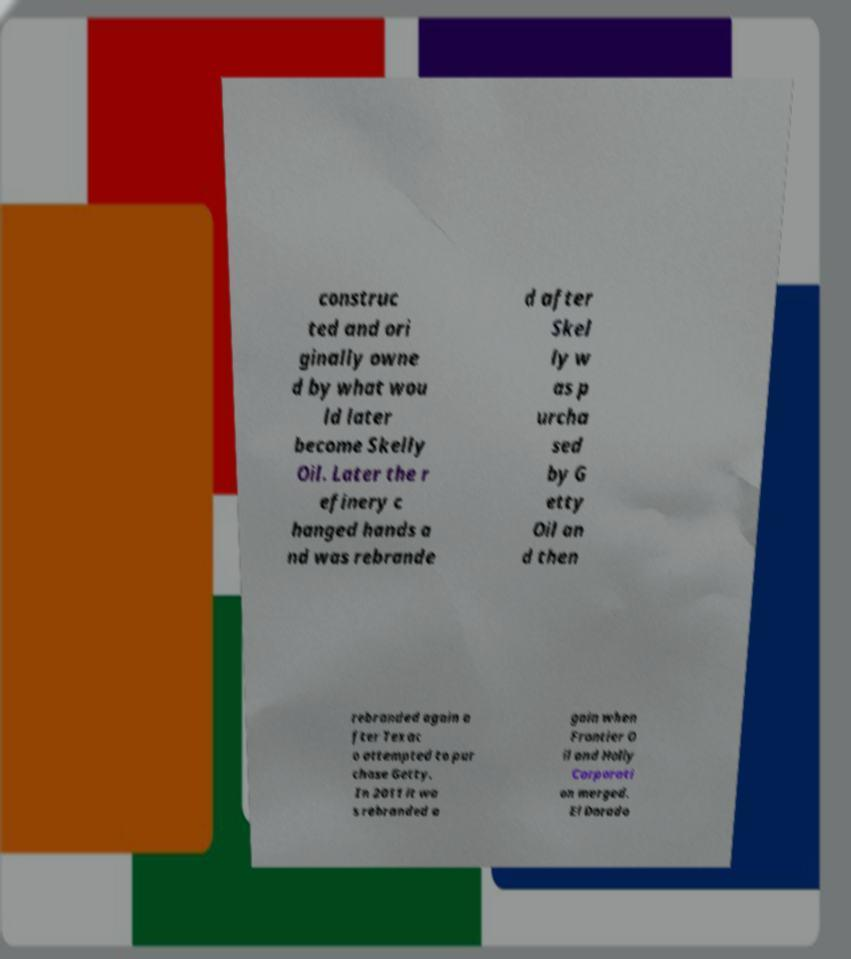There's text embedded in this image that I need extracted. Can you transcribe it verbatim? construc ted and ori ginally owne d by what wou ld later become Skelly Oil. Later the r efinery c hanged hands a nd was rebrande d after Skel ly w as p urcha sed by G etty Oil an d then rebranded again a fter Texac o attempted to pur chase Getty. In 2011 it wa s rebranded a gain when Frontier O il and Holly Corporati on merged. El Dorado 